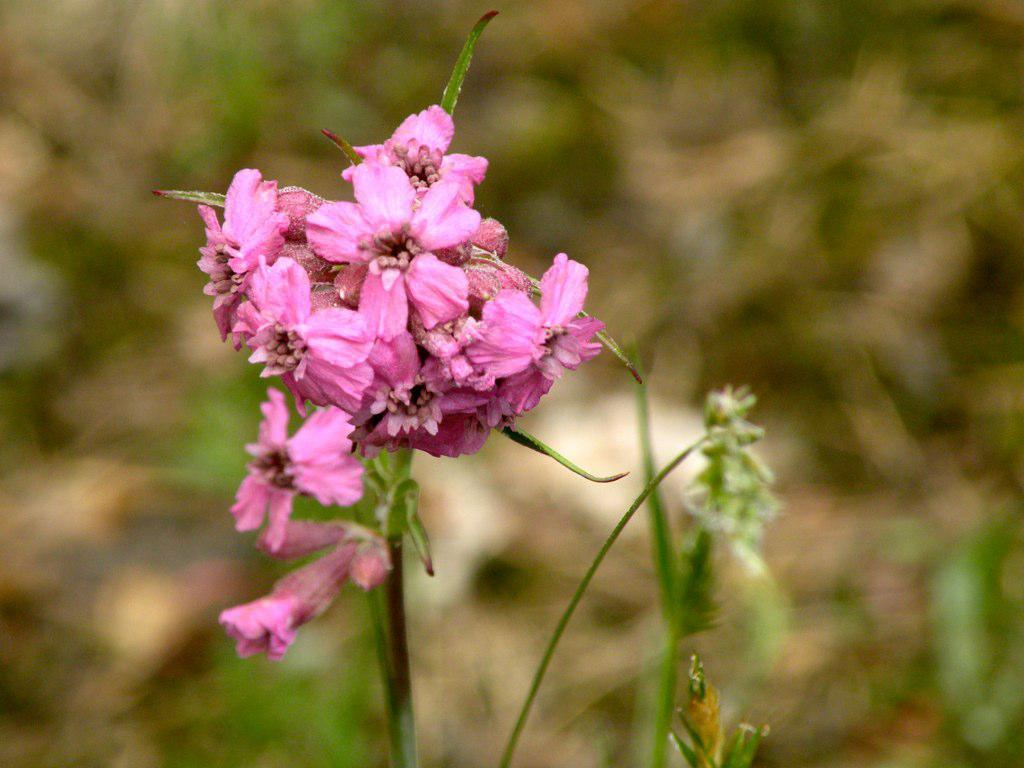What type of plants can be seen in the image? There are flowers in the image. What color is the background of the image? The background of the image is blue. How many dogs are present in the image? There are no dogs present in the image; it features flowers and a blue background. What type of legal advice is being given in the image? There is no lawyer or legal advice present in the image; it features flowers and a blue background. 